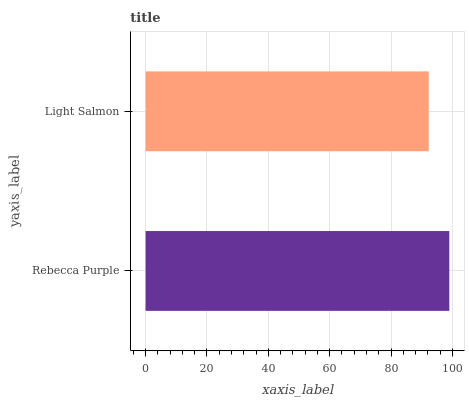Is Light Salmon the minimum?
Answer yes or no. Yes. Is Rebecca Purple the maximum?
Answer yes or no. Yes. Is Light Salmon the maximum?
Answer yes or no. No. Is Rebecca Purple greater than Light Salmon?
Answer yes or no. Yes. Is Light Salmon less than Rebecca Purple?
Answer yes or no. Yes. Is Light Salmon greater than Rebecca Purple?
Answer yes or no. No. Is Rebecca Purple less than Light Salmon?
Answer yes or no. No. Is Rebecca Purple the high median?
Answer yes or no. Yes. Is Light Salmon the low median?
Answer yes or no. Yes. Is Light Salmon the high median?
Answer yes or no. No. Is Rebecca Purple the low median?
Answer yes or no. No. 